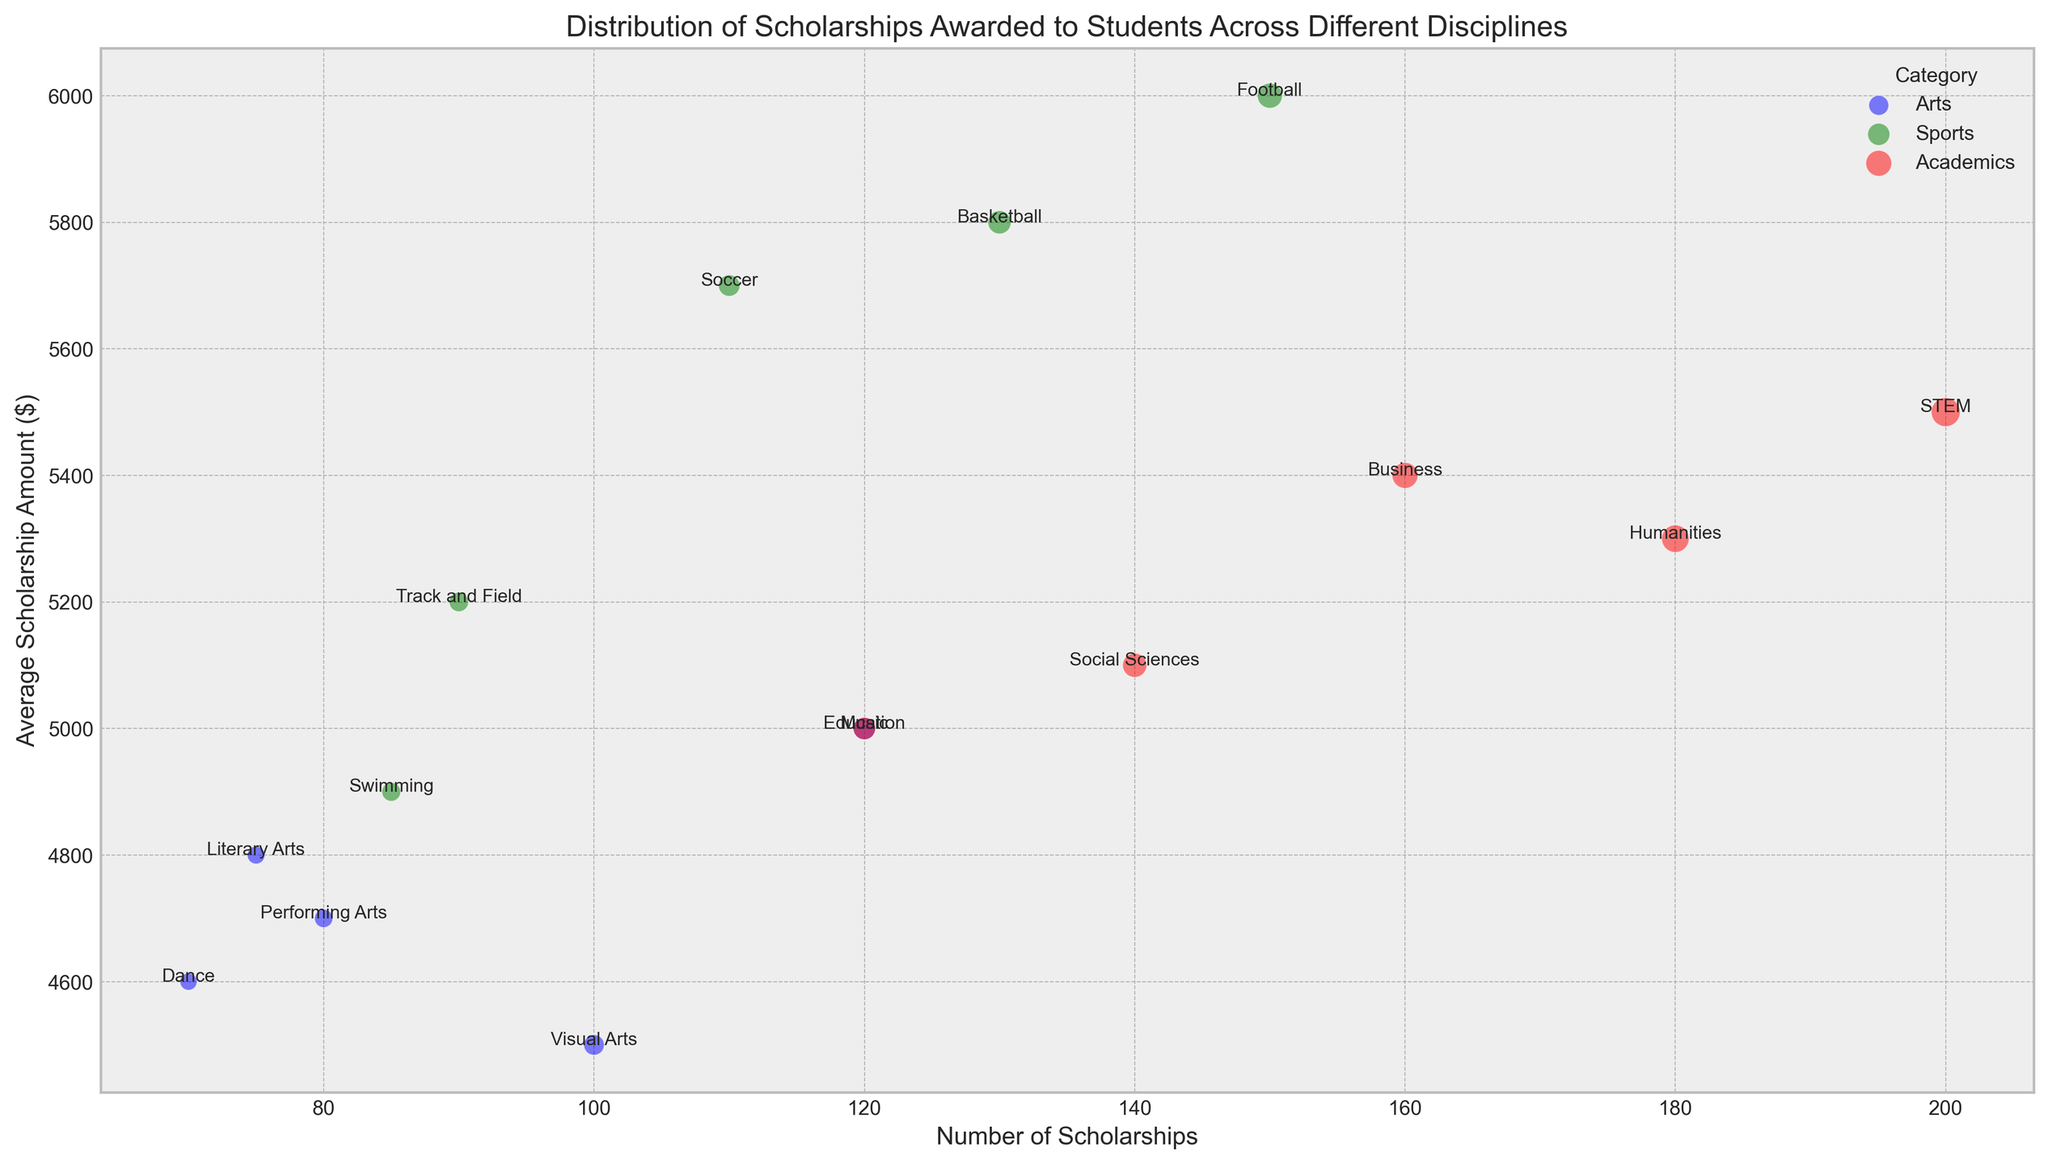What's the total number of scholarships for Arts disciplines? To find the total number of scholarships for Arts disciplines, sum the NumberOfScholarships for all subcategories under Arts. These are: 120 (Music) + 100 (Visual Arts) + 80 (Performing Arts) + 75 (Literary Arts) + 70 (Dance). The total is 120 + 100 + 80 + 75 + 70.
Answer: 445 Which category has the highest average scholarship amount? To determine the category with the highest average scholarship amount, compare the average amounts of all subcategories. Sports typically have higher average amounts. For Sports: Football (6000), Basketball (5800), Track and Field (5200), Soccer (5700), Swimming (4900). The highest among them is Football with 6000.
Answer: Sports Which subcategory has the largest bubble size and what does it represent? The subcategory with the largest bubble size represents the highest NumberOfScholarships. By visually checking the bubble sizes, STEM has the largest bubble size.
Answer: STEM What is the difference in the number of scholarships awarded between Football and Dance? To find the difference, subtract the NumberOfScholarships for Dance from Football. Football has 150 scholarships, while Dance has 70 scholarships. The difference is 150 - 70.
Answer: 80 Which subcategory within Academics has the lowest average scholarship amount? To find the subcategory with the lowest average scholarship amount within Academics, compare the average amounts of all subcategories: STEM (5500), Humanities (5300), Business (5400), Social Sciences (5100), Education (5000). The lowest is Education with 5000.
Answer: Education Between Music and Basketball, which one has more scholarships awarded and by how many? To compare the number of scholarships awarded between Music and Basketball, check the NumberOfScholarships for each subcategory: Music (120), Basketball (130). Basketball has 130 - 120 = 10 more scholarships than Music.
Answer: Basketball, 10 What is the average scholarship amount for subcategories in Sports? To find the average, sum the AverageAmount for all Sports subcategories and divide by the number of subcategories. Sports subcategories: Football (6000), Basketball (5800), Track and Field (5200), Soccer (5700), Swimming (4900). The sum is 6000 + 5800 + 5200 + 5700 + 4900 = 27600. Divide by 5 subcategories.
Answer: 5520 Which category has the highest variety of subcategories? To determine which category has the most subcategories, count the number of subcategories for each category. Arts has 5 subcategories, Sports has 5, and Academics has 5. Each category has the same variety.
Answer: All categories What is the combined average scholarship amount for Visual Arts and Dance? To find the combined average, sum the AverageAmount for both subcategories and divide by 2. Visual Arts has 4500, Dance has 4600. The combined average is (4500 + 4600) / 2 = 4550.
Answer: 4550 